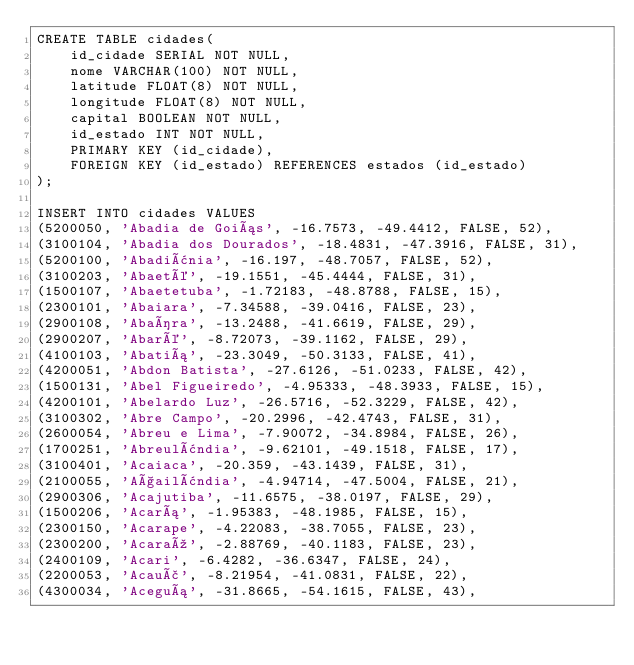<code> <loc_0><loc_0><loc_500><loc_500><_SQL_>CREATE TABLE cidades(
    id_cidade SERIAL NOT NULL,
    nome VARCHAR(100) NOT NULL,
    latitude FLOAT(8) NOT NULL,
    longitude FLOAT(8) NOT NULL,
    capital BOOLEAN NOT NULL,
    id_estado INT NOT NULL,
    PRIMARY KEY (id_cidade),
    FOREIGN KEY (id_estado) REFERENCES estados (id_estado)
);

INSERT INTO cidades VALUES
(5200050, 'Abadia de Goiás', -16.7573, -49.4412, FALSE, 52),
(3100104, 'Abadia dos Dourados', -18.4831, -47.3916, FALSE, 31),
(5200100, 'Abadiânia', -16.197, -48.7057, FALSE, 52),
(3100203, 'Abaeté', -19.1551, -45.4444, FALSE, 31),
(1500107, 'Abaetetuba', -1.72183, -48.8788, FALSE, 15),
(2300101, 'Abaiara', -7.34588, -39.0416, FALSE, 23),
(2900108, 'Abaíra', -13.2488, -41.6619, FALSE, 29),
(2900207, 'Abaré', -8.72073, -39.1162, FALSE, 29),
(4100103, 'Abatiá', -23.3049, -50.3133, FALSE, 41),
(4200051, 'Abdon Batista', -27.6126, -51.0233, FALSE, 42),
(1500131, 'Abel Figueiredo', -4.95333, -48.3933, FALSE, 15),
(4200101, 'Abelardo Luz', -26.5716, -52.3229, FALSE, 42),
(3100302, 'Abre Campo', -20.2996, -42.4743, FALSE, 31),
(2600054, 'Abreu e Lima', -7.90072, -34.8984, FALSE, 26),
(1700251, 'Abreulândia', -9.62101, -49.1518, FALSE, 17),
(3100401, 'Acaiaca', -20.359, -43.1439, FALSE, 31),
(2100055, 'Açailândia', -4.94714, -47.5004, FALSE, 21),
(2900306, 'Acajutiba', -11.6575, -38.0197, FALSE, 29),
(1500206, 'Acará', -1.95383, -48.1985, FALSE, 15),
(2300150, 'Acarape', -4.22083, -38.7055, FALSE, 23),
(2300200, 'Acaraú', -2.88769, -40.1183, FALSE, 23),
(2400109, 'Acari', -6.4282, -36.6347, FALSE, 24),
(2200053, 'Acauã', -8.21954, -41.0831, FALSE, 22),
(4300034, 'Aceguá', -31.8665, -54.1615, FALSE, 43),</code> 